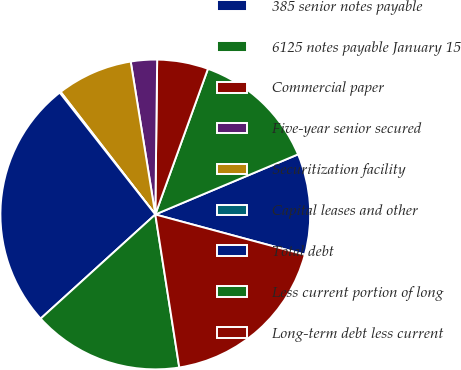Convert chart to OTSL. <chart><loc_0><loc_0><loc_500><loc_500><pie_chart><fcel>385 senior notes payable<fcel>6125 notes payable January 15<fcel>Commercial paper<fcel>Five-year senior secured<fcel>Securitization facility<fcel>Capital leases and other<fcel>Total debt<fcel>Less current portion of long<fcel>Long-term debt less current<nl><fcel>10.53%<fcel>13.14%<fcel>5.33%<fcel>2.73%<fcel>7.93%<fcel>0.12%<fcel>26.15%<fcel>15.74%<fcel>18.34%<nl></chart> 